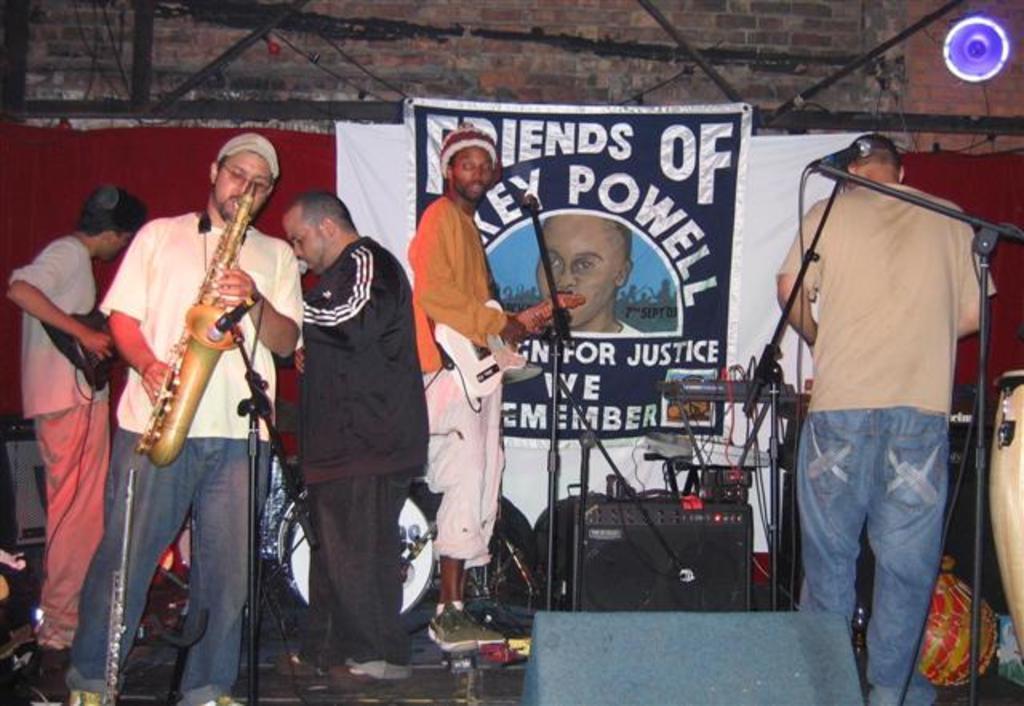Please provide a concise description of this image. In this picture we can see a group of people playing instruments and hear the person playing saxophone and the person beat boxing on mic and this person holding guitar in his hand and in background we can see a banner, light, musical instruments, speakers. 